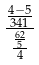<formula> <loc_0><loc_0><loc_500><loc_500>\frac { \frac { 4 - 5 } { 3 4 1 } } { \frac { \frac { 6 2 } { 5 } } { 4 } }</formula> 